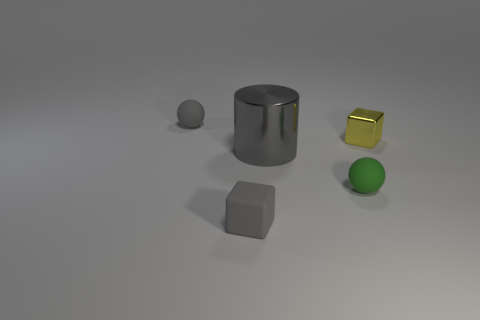Add 4 rubber things. How many objects exist? 9 Subtract all cylinders. How many objects are left? 4 Add 5 yellow objects. How many yellow objects are left? 6 Add 4 tiny gray balls. How many tiny gray balls exist? 5 Subtract 0 brown spheres. How many objects are left? 5 Subtract all green objects. Subtract all big gray objects. How many objects are left? 3 